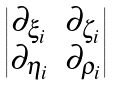Convert formula to latex. <formula><loc_0><loc_0><loc_500><loc_500>\begin{vmatrix} \partial _ { \xi _ { i } } & \partial _ { \zeta _ { i } } \\ \partial _ { \eta _ { i } } & \partial _ { \rho _ { i } } \end{vmatrix}</formula> 